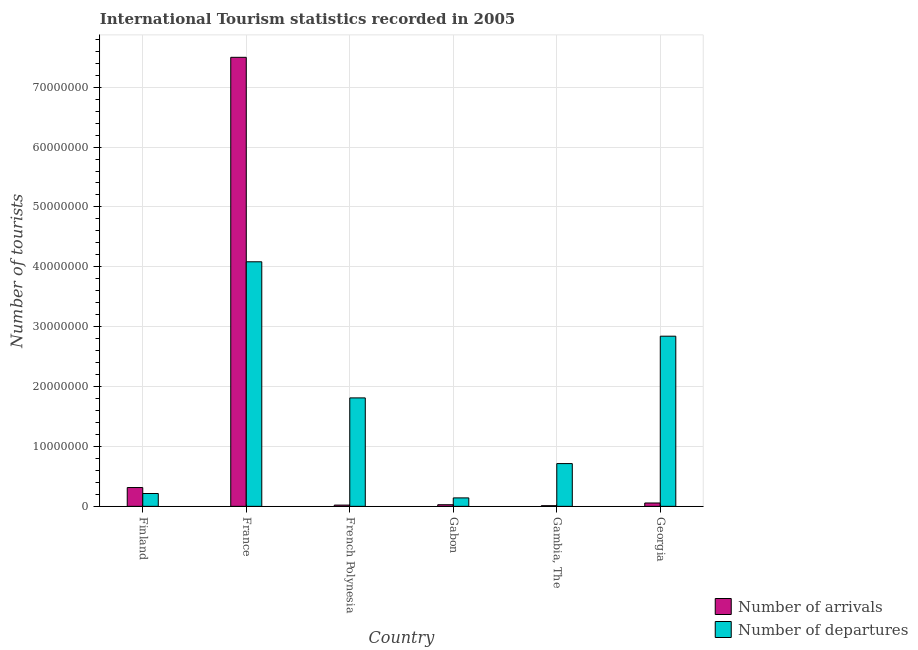How many groups of bars are there?
Your response must be concise. 6. Are the number of bars per tick equal to the number of legend labels?
Give a very brief answer. Yes. How many bars are there on the 5th tick from the left?
Offer a terse response. 2. How many bars are there on the 3rd tick from the right?
Your answer should be very brief. 2. In how many cases, is the number of bars for a given country not equal to the number of legend labels?
Your response must be concise. 0. What is the number of tourist arrivals in Gabon?
Provide a short and direct response. 2.69e+05. Across all countries, what is the maximum number of tourist arrivals?
Provide a short and direct response. 7.50e+07. Across all countries, what is the minimum number of tourist departures?
Offer a terse response. 1.41e+06. In which country was the number of tourist departures maximum?
Make the answer very short. France. In which country was the number of tourist arrivals minimum?
Your answer should be very brief. Gambia, The. What is the total number of tourist arrivals in the graph?
Your response must be concise. 7.93e+07. What is the difference between the number of tourist departures in Finland and that in Gambia, The?
Make the answer very short. -5.00e+06. What is the difference between the number of tourist arrivals in Gambia, The and the number of tourist departures in Gabon?
Provide a short and direct response. -1.30e+06. What is the average number of tourist departures per country?
Offer a very short reply. 1.63e+07. What is the difference between the number of tourist arrivals and number of tourist departures in Gabon?
Keep it short and to the point. -1.14e+06. What is the ratio of the number of tourist departures in French Polynesia to that in Gambia, The?
Make the answer very short. 2.54. Is the difference between the number of tourist arrivals in Finland and French Polynesia greater than the difference between the number of tourist departures in Finland and French Polynesia?
Keep it short and to the point. Yes. What is the difference between the highest and the second highest number of tourist departures?
Your response must be concise. 1.24e+07. What is the difference between the highest and the lowest number of tourist arrivals?
Offer a terse response. 7.49e+07. In how many countries, is the number of tourist arrivals greater than the average number of tourist arrivals taken over all countries?
Offer a terse response. 1. Is the sum of the number of tourist arrivals in Finland and Gambia, The greater than the maximum number of tourist departures across all countries?
Provide a succinct answer. No. What does the 2nd bar from the left in Finland represents?
Provide a succinct answer. Number of departures. What does the 1st bar from the right in Gambia, The represents?
Provide a succinct answer. Number of departures. Are all the bars in the graph horizontal?
Keep it short and to the point. No. What is the difference between two consecutive major ticks on the Y-axis?
Give a very brief answer. 1.00e+07. Where does the legend appear in the graph?
Offer a very short reply. Bottom right. What is the title of the graph?
Provide a short and direct response. International Tourism statistics recorded in 2005. What is the label or title of the Y-axis?
Provide a short and direct response. Number of tourists. What is the Number of tourists in Number of arrivals in Finland?
Provide a short and direct response. 3.14e+06. What is the Number of tourists in Number of departures in Finland?
Keep it short and to the point. 2.14e+06. What is the Number of tourists in Number of arrivals in France?
Keep it short and to the point. 7.50e+07. What is the Number of tourists in Number of departures in France?
Provide a succinct answer. 4.08e+07. What is the Number of tourists of Number of arrivals in French Polynesia?
Your answer should be very brief. 2.08e+05. What is the Number of tourists in Number of departures in French Polynesia?
Offer a very short reply. 1.81e+07. What is the Number of tourists in Number of arrivals in Gabon?
Keep it short and to the point. 2.69e+05. What is the Number of tourists of Number of departures in Gabon?
Keep it short and to the point. 1.41e+06. What is the Number of tourists in Number of arrivals in Gambia, The?
Give a very brief answer. 1.08e+05. What is the Number of tourists in Number of departures in Gambia, The?
Give a very brief answer. 7.14e+06. What is the Number of tourists of Number of arrivals in Georgia?
Ensure brevity in your answer.  5.60e+05. What is the Number of tourists of Number of departures in Georgia?
Make the answer very short. 2.84e+07. Across all countries, what is the maximum Number of tourists in Number of arrivals?
Your answer should be very brief. 7.50e+07. Across all countries, what is the maximum Number of tourists in Number of departures?
Make the answer very short. 4.08e+07. Across all countries, what is the minimum Number of tourists in Number of arrivals?
Offer a terse response. 1.08e+05. Across all countries, what is the minimum Number of tourists of Number of departures?
Ensure brevity in your answer.  1.41e+06. What is the total Number of tourists of Number of arrivals in the graph?
Provide a short and direct response. 7.93e+07. What is the total Number of tourists of Number of departures in the graph?
Provide a short and direct response. 9.81e+07. What is the difference between the Number of tourists of Number of arrivals in Finland and that in France?
Your response must be concise. -7.18e+07. What is the difference between the Number of tourists in Number of departures in Finland and that in France?
Offer a very short reply. -3.87e+07. What is the difference between the Number of tourists of Number of arrivals in Finland and that in French Polynesia?
Make the answer very short. 2.93e+06. What is the difference between the Number of tourists of Number of departures in Finland and that in French Polynesia?
Offer a very short reply. -1.60e+07. What is the difference between the Number of tourists in Number of arrivals in Finland and that in Gabon?
Give a very brief answer. 2.87e+06. What is the difference between the Number of tourists of Number of departures in Finland and that in Gabon?
Your response must be concise. 7.34e+05. What is the difference between the Number of tourists of Number of arrivals in Finland and that in Gambia, The?
Keep it short and to the point. 3.03e+06. What is the difference between the Number of tourists in Number of departures in Finland and that in Gambia, The?
Give a very brief answer. -5.00e+06. What is the difference between the Number of tourists in Number of arrivals in Finland and that in Georgia?
Offer a terse response. 2.58e+06. What is the difference between the Number of tourists of Number of departures in Finland and that in Georgia?
Offer a terse response. -2.63e+07. What is the difference between the Number of tourists of Number of arrivals in France and that in French Polynesia?
Ensure brevity in your answer.  7.48e+07. What is the difference between the Number of tourists of Number of departures in France and that in French Polynesia?
Your answer should be compact. 2.27e+07. What is the difference between the Number of tourists of Number of arrivals in France and that in Gabon?
Offer a very short reply. 7.47e+07. What is the difference between the Number of tourists of Number of departures in France and that in Gabon?
Your answer should be compact. 3.94e+07. What is the difference between the Number of tourists in Number of arrivals in France and that in Gambia, The?
Provide a short and direct response. 7.49e+07. What is the difference between the Number of tourists in Number of departures in France and that in Gambia, The?
Give a very brief answer. 3.37e+07. What is the difference between the Number of tourists in Number of arrivals in France and that in Georgia?
Your answer should be compact. 7.44e+07. What is the difference between the Number of tourists of Number of departures in France and that in Georgia?
Provide a short and direct response. 1.24e+07. What is the difference between the Number of tourists in Number of arrivals in French Polynesia and that in Gabon?
Make the answer very short. -6.10e+04. What is the difference between the Number of tourists in Number of departures in French Polynesia and that in Gabon?
Give a very brief answer. 1.67e+07. What is the difference between the Number of tourists of Number of arrivals in French Polynesia and that in Gambia, The?
Provide a short and direct response. 1.00e+05. What is the difference between the Number of tourists of Number of departures in French Polynesia and that in Gambia, The?
Ensure brevity in your answer.  1.10e+07. What is the difference between the Number of tourists of Number of arrivals in French Polynesia and that in Georgia?
Make the answer very short. -3.52e+05. What is the difference between the Number of tourists in Number of departures in French Polynesia and that in Georgia?
Give a very brief answer. -1.03e+07. What is the difference between the Number of tourists of Number of arrivals in Gabon and that in Gambia, The?
Ensure brevity in your answer.  1.61e+05. What is the difference between the Number of tourists of Number of departures in Gabon and that in Gambia, The?
Give a very brief answer. -5.73e+06. What is the difference between the Number of tourists of Number of arrivals in Gabon and that in Georgia?
Keep it short and to the point. -2.91e+05. What is the difference between the Number of tourists in Number of departures in Gabon and that in Georgia?
Offer a terse response. -2.70e+07. What is the difference between the Number of tourists in Number of arrivals in Gambia, The and that in Georgia?
Provide a short and direct response. -4.52e+05. What is the difference between the Number of tourists of Number of departures in Gambia, The and that in Georgia?
Provide a short and direct response. -2.13e+07. What is the difference between the Number of tourists in Number of arrivals in Finland and the Number of tourists in Number of departures in France?
Provide a succinct answer. -3.77e+07. What is the difference between the Number of tourists of Number of arrivals in Finland and the Number of tourists of Number of departures in French Polynesia?
Your answer should be very brief. -1.50e+07. What is the difference between the Number of tourists in Number of arrivals in Finland and the Number of tourists in Number of departures in Gabon?
Provide a short and direct response. 1.73e+06. What is the difference between the Number of tourists in Number of arrivals in Finland and the Number of tourists in Number of departures in Gambia, The?
Make the answer very short. -4.00e+06. What is the difference between the Number of tourists of Number of arrivals in Finland and the Number of tourists of Number of departures in Georgia?
Provide a succinct answer. -2.53e+07. What is the difference between the Number of tourists of Number of arrivals in France and the Number of tourists of Number of departures in French Polynesia?
Make the answer very short. 5.69e+07. What is the difference between the Number of tourists of Number of arrivals in France and the Number of tourists of Number of departures in Gabon?
Offer a very short reply. 7.36e+07. What is the difference between the Number of tourists of Number of arrivals in France and the Number of tourists of Number of departures in Gambia, The?
Keep it short and to the point. 6.78e+07. What is the difference between the Number of tourists in Number of arrivals in France and the Number of tourists in Number of departures in Georgia?
Give a very brief answer. 4.66e+07. What is the difference between the Number of tourists of Number of arrivals in French Polynesia and the Number of tourists of Number of departures in Gabon?
Offer a very short reply. -1.20e+06. What is the difference between the Number of tourists in Number of arrivals in French Polynesia and the Number of tourists in Number of departures in Gambia, The?
Ensure brevity in your answer.  -6.93e+06. What is the difference between the Number of tourists of Number of arrivals in French Polynesia and the Number of tourists of Number of departures in Georgia?
Ensure brevity in your answer.  -2.82e+07. What is the difference between the Number of tourists of Number of arrivals in Gabon and the Number of tourists of Number of departures in Gambia, The?
Provide a short and direct response. -6.87e+06. What is the difference between the Number of tourists in Number of arrivals in Gabon and the Number of tourists in Number of departures in Georgia?
Provide a succinct answer. -2.81e+07. What is the difference between the Number of tourists in Number of arrivals in Gambia, The and the Number of tourists in Number of departures in Georgia?
Your response must be concise. -2.83e+07. What is the average Number of tourists in Number of arrivals per country?
Offer a very short reply. 1.32e+07. What is the average Number of tourists of Number of departures per country?
Ensure brevity in your answer.  1.63e+07. What is the difference between the Number of tourists of Number of arrivals and Number of tourists of Number of departures in Finland?
Provide a short and direct response. 9.96e+05. What is the difference between the Number of tourists of Number of arrivals and Number of tourists of Number of departures in France?
Provide a short and direct response. 3.41e+07. What is the difference between the Number of tourists of Number of arrivals and Number of tourists of Number of departures in French Polynesia?
Provide a succinct answer. -1.79e+07. What is the difference between the Number of tourists in Number of arrivals and Number of tourists in Number of departures in Gabon?
Your response must be concise. -1.14e+06. What is the difference between the Number of tourists in Number of arrivals and Number of tourists in Number of departures in Gambia, The?
Ensure brevity in your answer.  -7.03e+06. What is the difference between the Number of tourists of Number of arrivals and Number of tourists of Number of departures in Georgia?
Make the answer very short. -2.79e+07. What is the ratio of the Number of tourists of Number of arrivals in Finland to that in France?
Offer a terse response. 0.04. What is the ratio of the Number of tourists of Number of departures in Finland to that in France?
Make the answer very short. 0.05. What is the ratio of the Number of tourists in Number of arrivals in Finland to that in French Polynesia?
Your answer should be compact. 15.1. What is the ratio of the Number of tourists in Number of departures in Finland to that in French Polynesia?
Provide a short and direct response. 0.12. What is the ratio of the Number of tourists in Number of arrivals in Finland to that in Gabon?
Give a very brief answer. 11.67. What is the ratio of the Number of tourists of Number of departures in Finland to that in Gabon?
Keep it short and to the point. 1.52. What is the ratio of the Number of tourists of Number of arrivals in Finland to that in Gambia, The?
Make the answer very short. 29.07. What is the ratio of the Number of tourists of Number of departures in Finland to that in Gambia, The?
Your response must be concise. 0.3. What is the ratio of the Number of tourists of Number of arrivals in Finland to that in Georgia?
Offer a very short reply. 5.61. What is the ratio of the Number of tourists of Number of departures in Finland to that in Georgia?
Ensure brevity in your answer.  0.08. What is the ratio of the Number of tourists in Number of arrivals in France to that in French Polynesia?
Offer a terse response. 360.52. What is the ratio of the Number of tourists of Number of departures in France to that in French Polynesia?
Provide a succinct answer. 2.26. What is the ratio of the Number of tourists in Number of arrivals in France to that in Gabon?
Your answer should be very brief. 278.77. What is the ratio of the Number of tourists in Number of departures in France to that in Gabon?
Provide a short and direct response. 28.97. What is the ratio of the Number of tourists in Number of arrivals in France to that in Gambia, The?
Keep it short and to the point. 694.33. What is the ratio of the Number of tourists of Number of departures in France to that in Gambia, The?
Provide a short and direct response. 5.72. What is the ratio of the Number of tourists of Number of arrivals in France to that in Georgia?
Your answer should be compact. 133.91. What is the ratio of the Number of tourists in Number of departures in France to that in Georgia?
Your answer should be compact. 1.44. What is the ratio of the Number of tourists in Number of arrivals in French Polynesia to that in Gabon?
Offer a terse response. 0.77. What is the ratio of the Number of tourists of Number of departures in French Polynesia to that in Gabon?
Offer a very short reply. 12.84. What is the ratio of the Number of tourists of Number of arrivals in French Polynesia to that in Gambia, The?
Offer a terse response. 1.93. What is the ratio of the Number of tourists of Number of departures in French Polynesia to that in Gambia, The?
Give a very brief answer. 2.54. What is the ratio of the Number of tourists of Number of arrivals in French Polynesia to that in Georgia?
Ensure brevity in your answer.  0.37. What is the ratio of the Number of tourists of Number of departures in French Polynesia to that in Georgia?
Offer a terse response. 0.64. What is the ratio of the Number of tourists of Number of arrivals in Gabon to that in Gambia, The?
Your response must be concise. 2.49. What is the ratio of the Number of tourists in Number of departures in Gabon to that in Gambia, The?
Offer a terse response. 0.2. What is the ratio of the Number of tourists of Number of arrivals in Gabon to that in Georgia?
Your answer should be compact. 0.48. What is the ratio of the Number of tourists of Number of departures in Gabon to that in Georgia?
Your response must be concise. 0.05. What is the ratio of the Number of tourists in Number of arrivals in Gambia, The to that in Georgia?
Your response must be concise. 0.19. What is the ratio of the Number of tourists in Number of departures in Gambia, The to that in Georgia?
Make the answer very short. 0.25. What is the difference between the highest and the second highest Number of tourists in Number of arrivals?
Your answer should be very brief. 7.18e+07. What is the difference between the highest and the second highest Number of tourists in Number of departures?
Offer a terse response. 1.24e+07. What is the difference between the highest and the lowest Number of tourists of Number of arrivals?
Your response must be concise. 7.49e+07. What is the difference between the highest and the lowest Number of tourists in Number of departures?
Make the answer very short. 3.94e+07. 